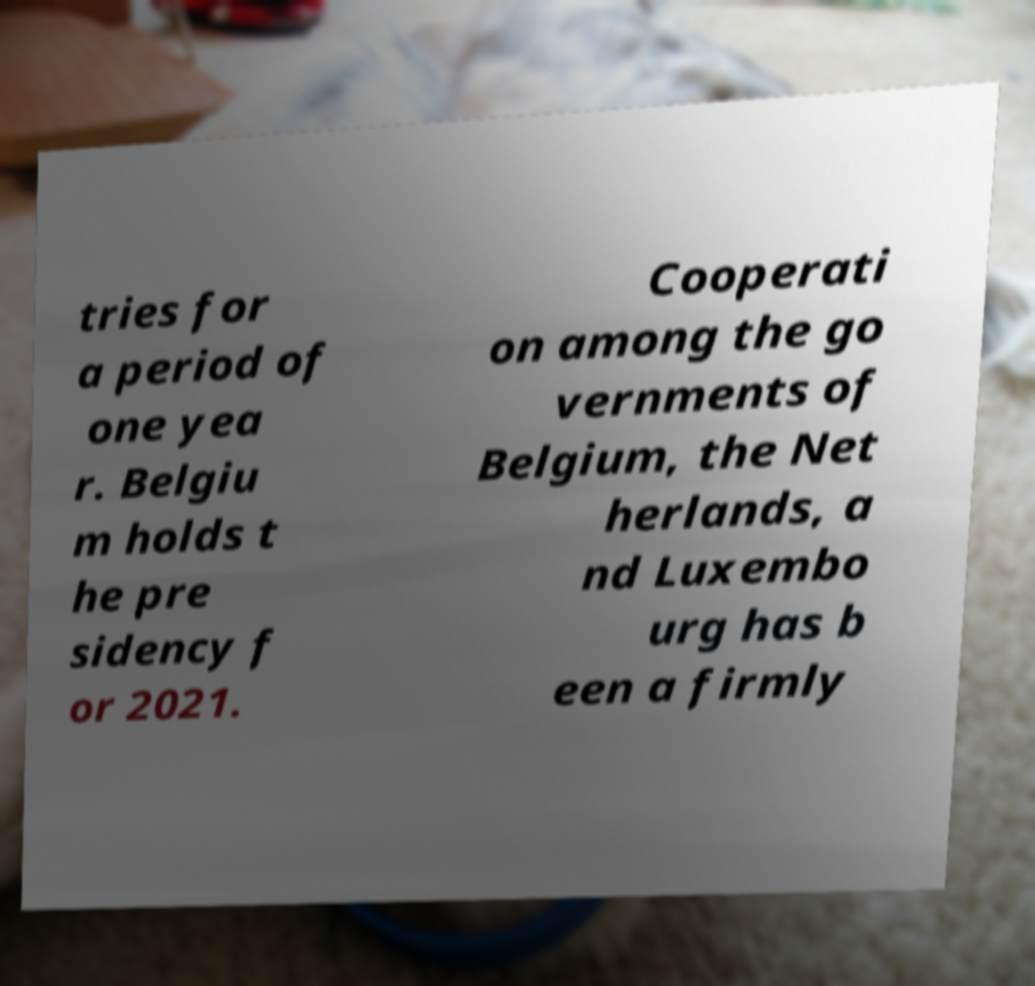What messages or text are displayed in this image? I need them in a readable, typed format. tries for a period of one yea r. Belgiu m holds t he pre sidency f or 2021. Cooperati on among the go vernments of Belgium, the Net herlands, a nd Luxembo urg has b een a firmly 